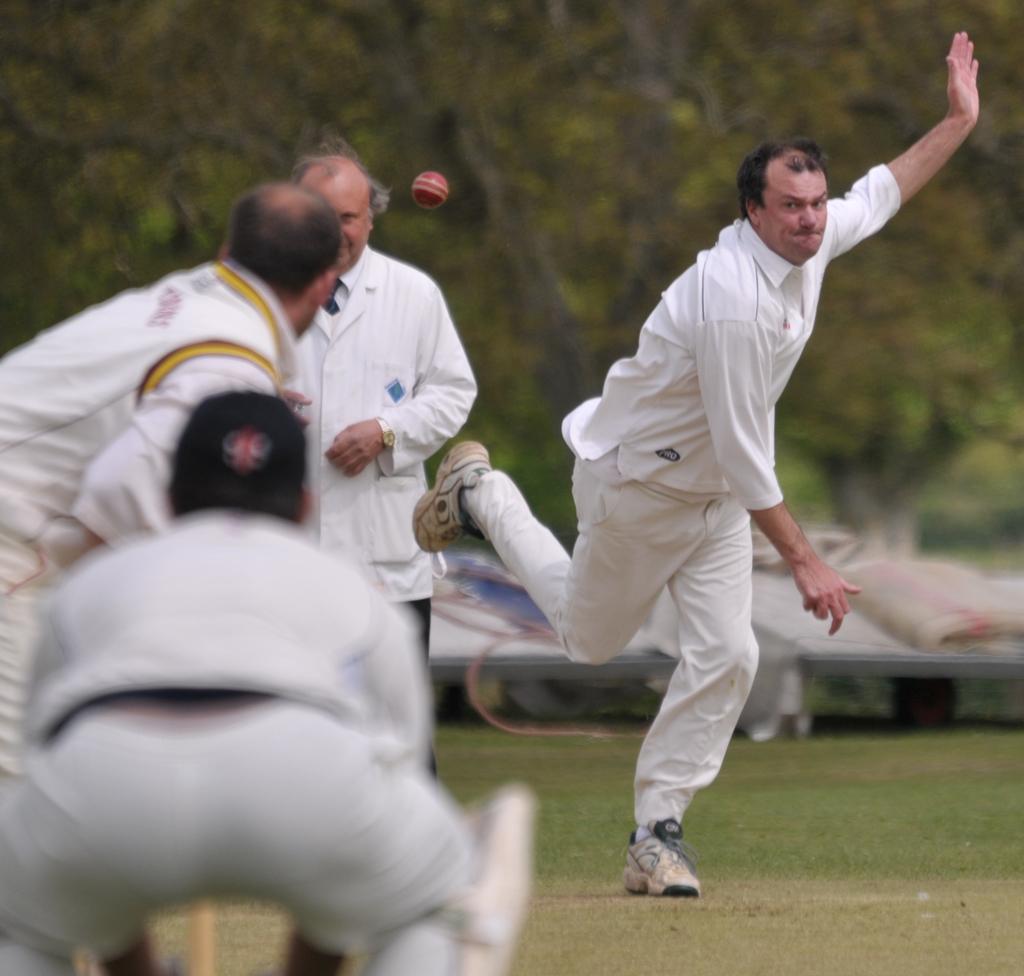Can you describe this image briefly? There are players in white color dresses playing cricket in the ground. There is an empire in white color shirt standing in the ground. In the background, there are trees and there are other objects. 